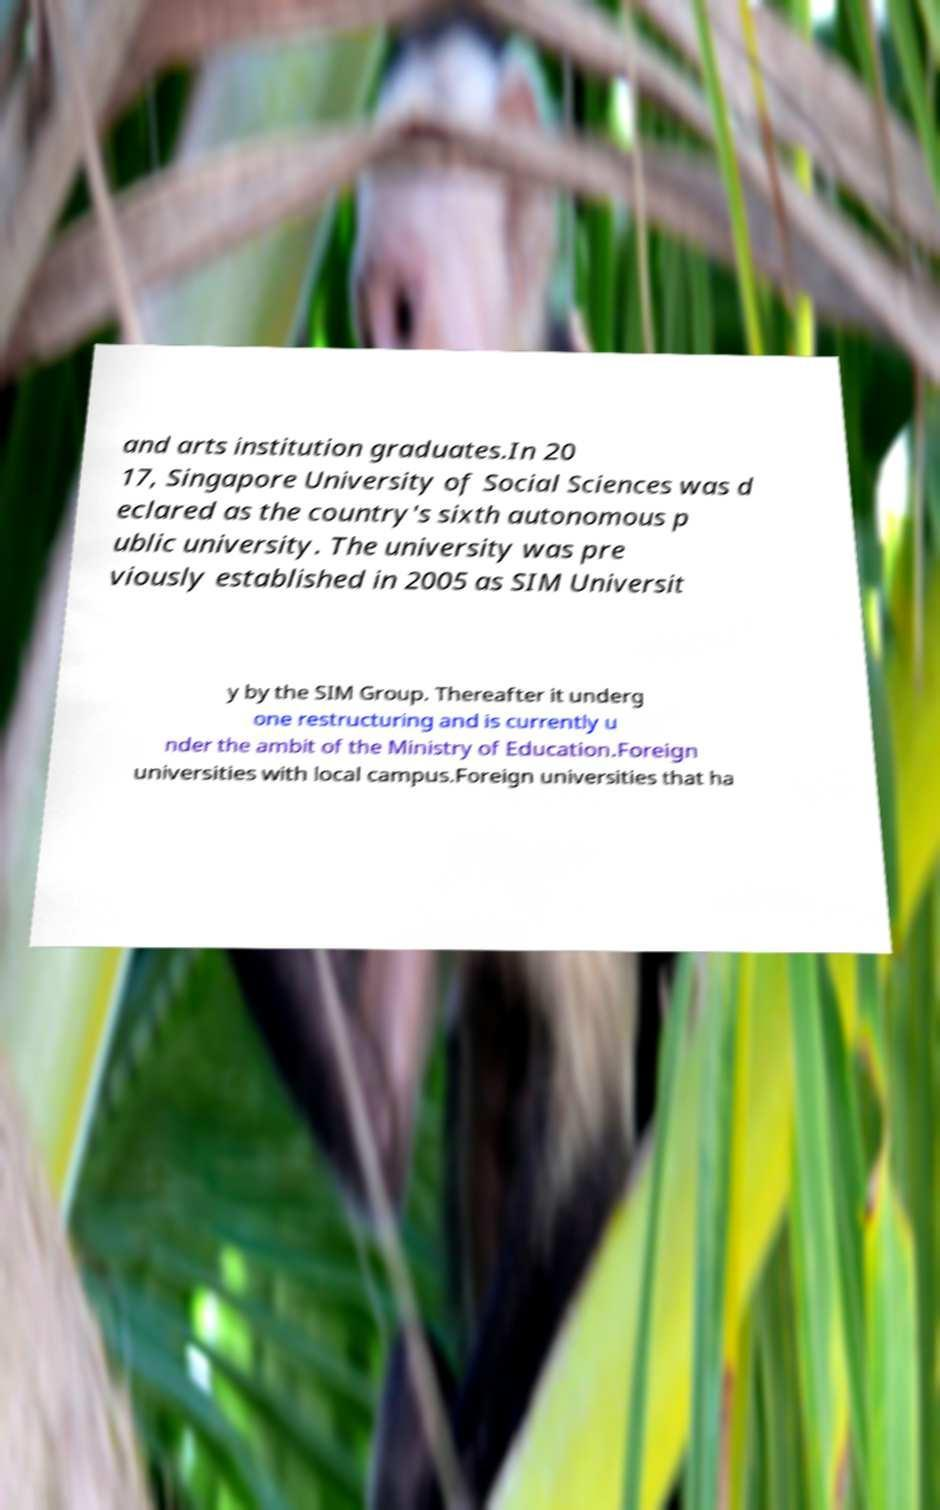For documentation purposes, I need the text within this image transcribed. Could you provide that? and arts institution graduates.In 20 17, Singapore University of Social Sciences was d eclared as the country's sixth autonomous p ublic university. The university was pre viously established in 2005 as SIM Universit y by the SIM Group. Thereafter it underg one restructuring and is currently u nder the ambit of the Ministry of Education.Foreign universities with local campus.Foreign universities that ha 